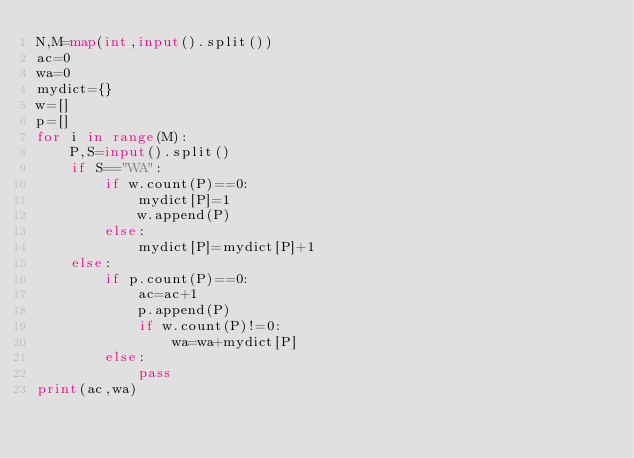Convert code to text. <code><loc_0><loc_0><loc_500><loc_500><_Python_>N,M=map(int,input().split())
ac=0
wa=0
mydict={}
w=[]
p=[]
for i in range(M):
    P,S=input().split()
    if S=="WA":
        if w.count(P)==0:
            mydict[P]=1
            w.append(P) 
        else:
            mydict[P]=mydict[P]+1
    else:
        if p.count(P)==0:
            ac=ac+1
            p.append(P)
            if w.count(P)!=0:
                wa=wa+mydict[P]
        else:
            pass
print(ac,wa)

        



</code> 